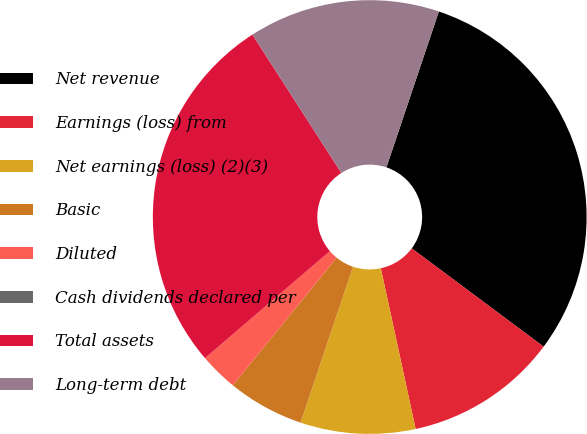Convert chart. <chart><loc_0><loc_0><loc_500><loc_500><pie_chart><fcel>Net revenue<fcel>Earnings (loss) from<fcel>Net earnings (loss) (2)(3)<fcel>Basic<fcel>Diluted<fcel>Cash dividends declared per<fcel>Total assets<fcel>Long-term debt<nl><fcel>30.03%<fcel>11.41%<fcel>8.56%<fcel>5.71%<fcel>2.85%<fcel>0.0%<fcel>27.18%<fcel>14.26%<nl></chart> 